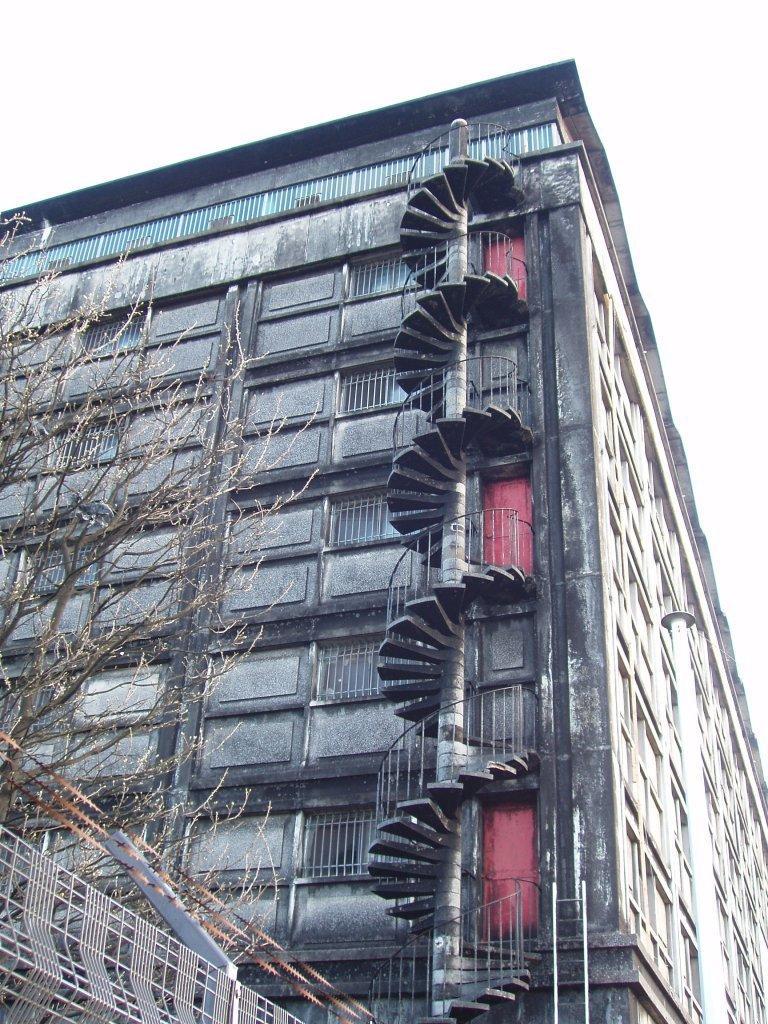Please provide a concise description of this image. In this image there is the sky towards the top of the image, there is a building, there are staircase, there is a tree towards the left of the image, there are objects towards the bottom of the image. 